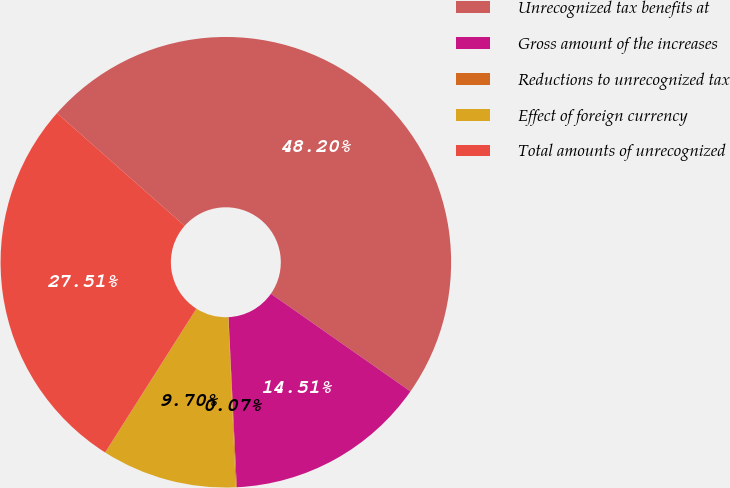Convert chart. <chart><loc_0><loc_0><loc_500><loc_500><pie_chart><fcel>Unrecognized tax benefits at<fcel>Gross amount of the increases<fcel>Reductions to unrecognized tax<fcel>Effect of foreign currency<fcel>Total amounts of unrecognized<nl><fcel>48.2%<fcel>14.51%<fcel>0.07%<fcel>9.7%<fcel>27.51%<nl></chart> 